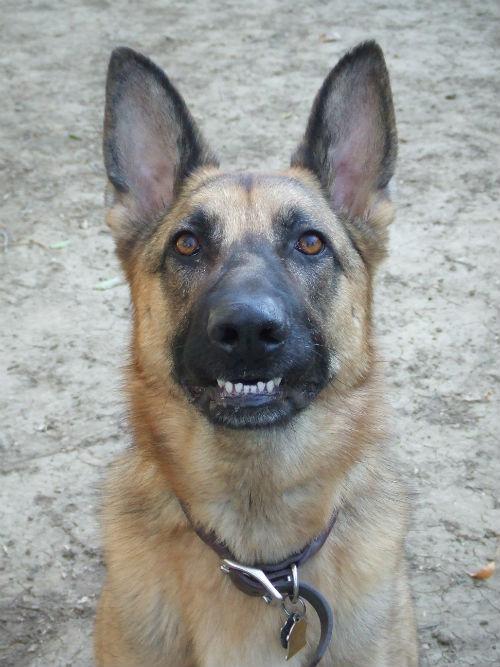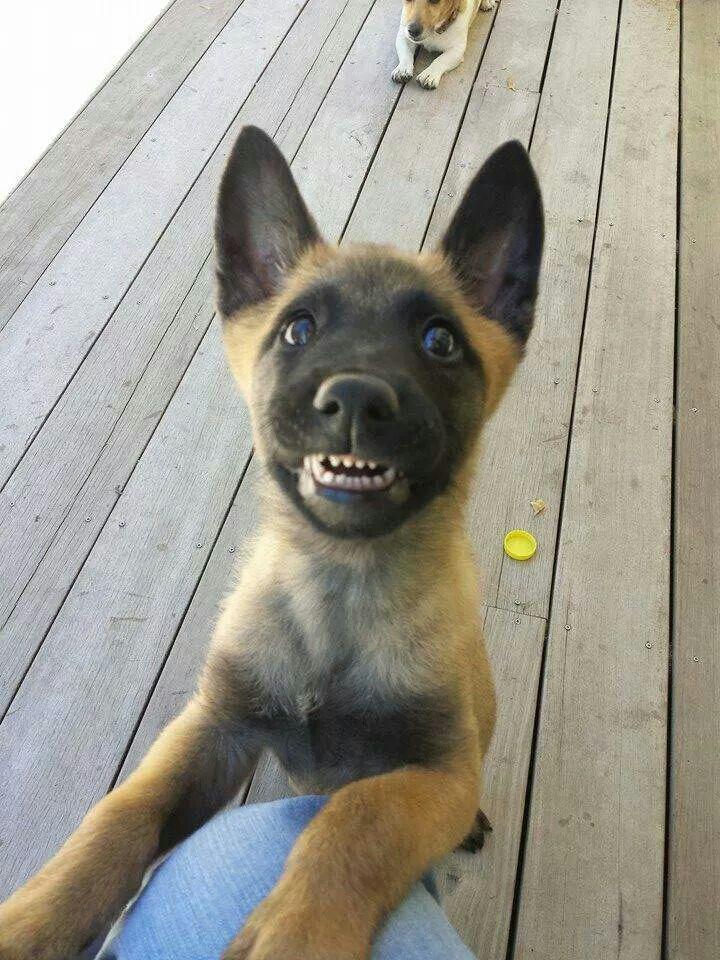The first image is the image on the left, the second image is the image on the right. Assess this claim about the two images: "A little dog in one image, with ears and tail standing up, has one front paw up in a walking stance.". Correct or not? Answer yes or no. No. The first image is the image on the left, the second image is the image on the right. Assess this claim about the two images: "A brown puppy has a visible leash.". Correct or not? Answer yes or no. No. 